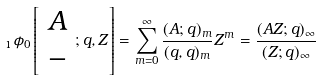<formula> <loc_0><loc_0><loc_500><loc_500>\, _ { 1 } \phi _ { 0 } \left [ \begin{array} { c } A \\ - \end{array} ; q , Z \right ] = \sum _ { m = 0 } ^ { \infty } \frac { ( A ; q ) _ { m } } { ( q , q ) _ { m } } Z ^ { m } = \frac { ( A Z ; q ) _ { \infty } } { ( Z ; q ) _ { \infty } }</formula> 